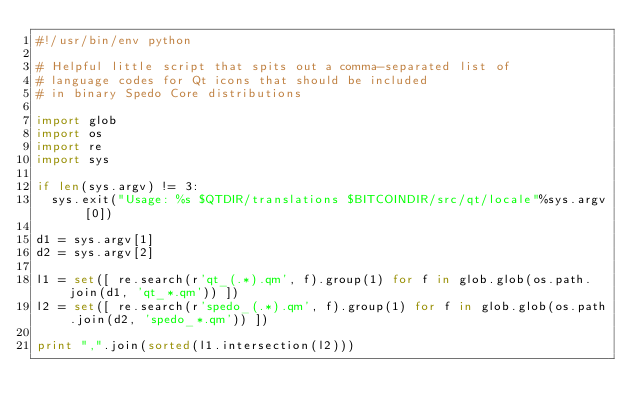Convert code to text. <code><loc_0><loc_0><loc_500><loc_500><_Python_>#!/usr/bin/env python

# Helpful little script that spits out a comma-separated list of
# language codes for Qt icons that should be included
# in binary Spedo Core distributions

import glob
import os
import re
import sys

if len(sys.argv) != 3:
  sys.exit("Usage: %s $QTDIR/translations $BITCOINDIR/src/qt/locale"%sys.argv[0])

d1 = sys.argv[1]
d2 = sys.argv[2]

l1 = set([ re.search(r'qt_(.*).qm', f).group(1) for f in glob.glob(os.path.join(d1, 'qt_*.qm')) ])
l2 = set([ re.search(r'spedo_(.*).qm', f).group(1) for f in glob.glob(os.path.join(d2, 'spedo_*.qm')) ])

print ",".join(sorted(l1.intersection(l2)))

</code> 